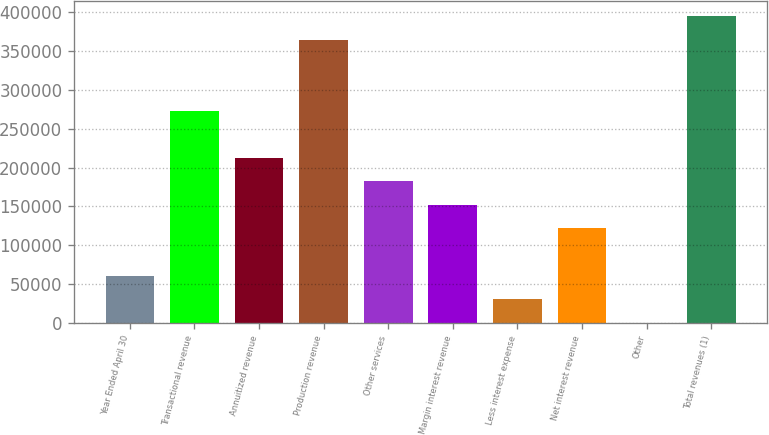<chart> <loc_0><loc_0><loc_500><loc_500><bar_chart><fcel>Year Ended April 30<fcel>Transactional revenue<fcel>Annuitized revenue<fcel>Production revenue<fcel>Other services<fcel>Margin interest revenue<fcel>Less interest expense<fcel>Net interest revenue<fcel>Other<fcel>Total revenues (1)<nl><fcel>60798<fcel>273360<fcel>212628<fcel>364458<fcel>182262<fcel>151896<fcel>30432<fcel>121530<fcel>66<fcel>394824<nl></chart> 